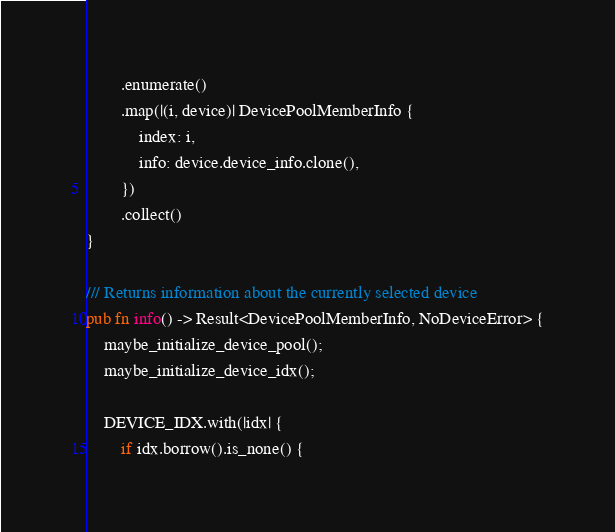Convert code to text. <code><loc_0><loc_0><loc_500><loc_500><_Rust_>        .enumerate()
        .map(|(i, device)| DevicePoolMemberInfo {
            index: i,
            info: device.device_info.clone(),
        })
        .collect()
}

/// Returns information about the currently selected device
pub fn info() -> Result<DevicePoolMemberInfo, NoDeviceError> {
    maybe_initialize_device_pool();
    maybe_initialize_device_idx();

    DEVICE_IDX.with(|idx| {
        if idx.borrow().is_none() {</code> 